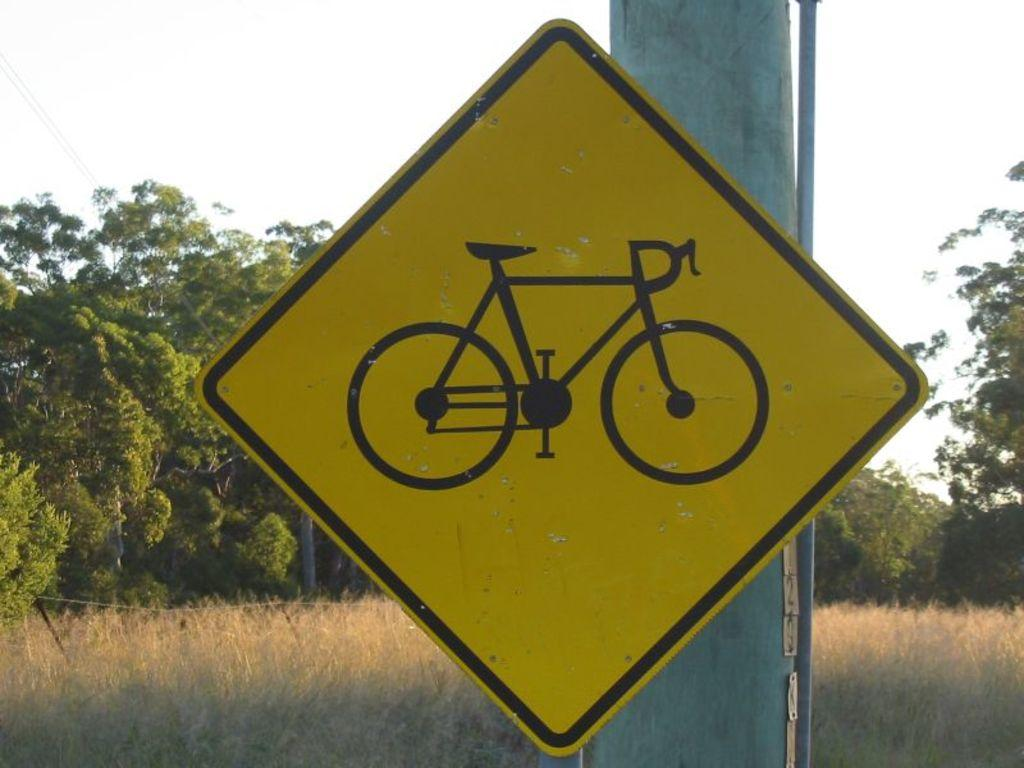What is located on a pole in the image? There is a sign board on a pole in the image. What type of vegetation is on the left side of the image? There are trees on the left side of the image. What is visible at the top of the image? The sky is visible at the top of the image. What color is the finger on the sign board in the image? There is no finger present on the sign board in the image. What type of scale can be seen in the image? There is no scale present in the image. 